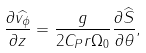Convert formula to latex. <formula><loc_0><loc_0><loc_500><loc_500>\frac { \partial \widehat { v _ { \phi } } } { \partial z } = \frac { g } { 2 C _ { P } r \Omega _ { 0 } } \frac { \partial \widehat { S } } { \partial \theta } ,</formula> 